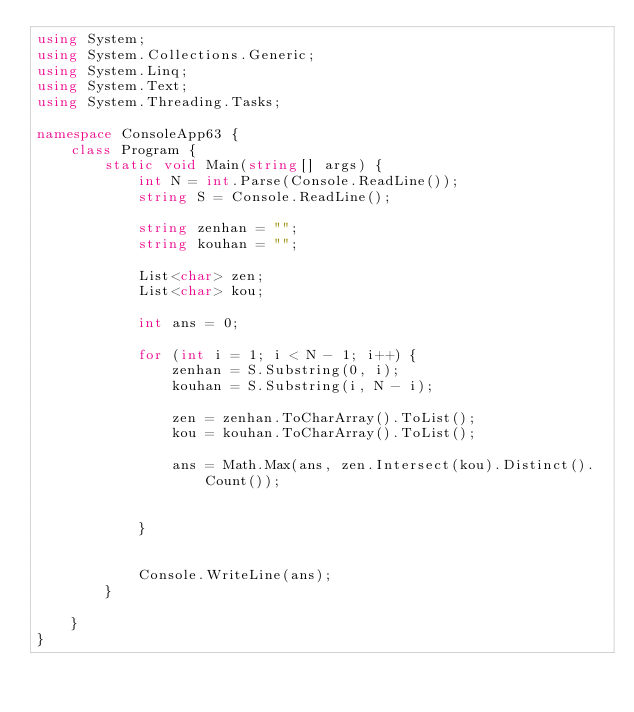Convert code to text. <code><loc_0><loc_0><loc_500><loc_500><_C#_>using System;
using System.Collections.Generic;
using System.Linq;
using System.Text;
using System.Threading.Tasks;

namespace ConsoleApp63 {
    class Program {
        static void Main(string[] args) {
            int N = int.Parse(Console.ReadLine());
            string S = Console.ReadLine();

            string zenhan = "";
            string kouhan = "";

            List<char> zen;
            List<char> kou;

            int ans = 0;

            for (int i = 1; i < N - 1; i++) {
                zenhan = S.Substring(0, i);
                kouhan = S.Substring(i, N - i);

                zen = zenhan.ToCharArray().ToList();
                kou = kouhan.ToCharArray().ToList();

                ans = Math.Max(ans, zen.Intersect(kou).Distinct().Count());


            }


            Console.WriteLine(ans);
        }

    }
}
</code> 